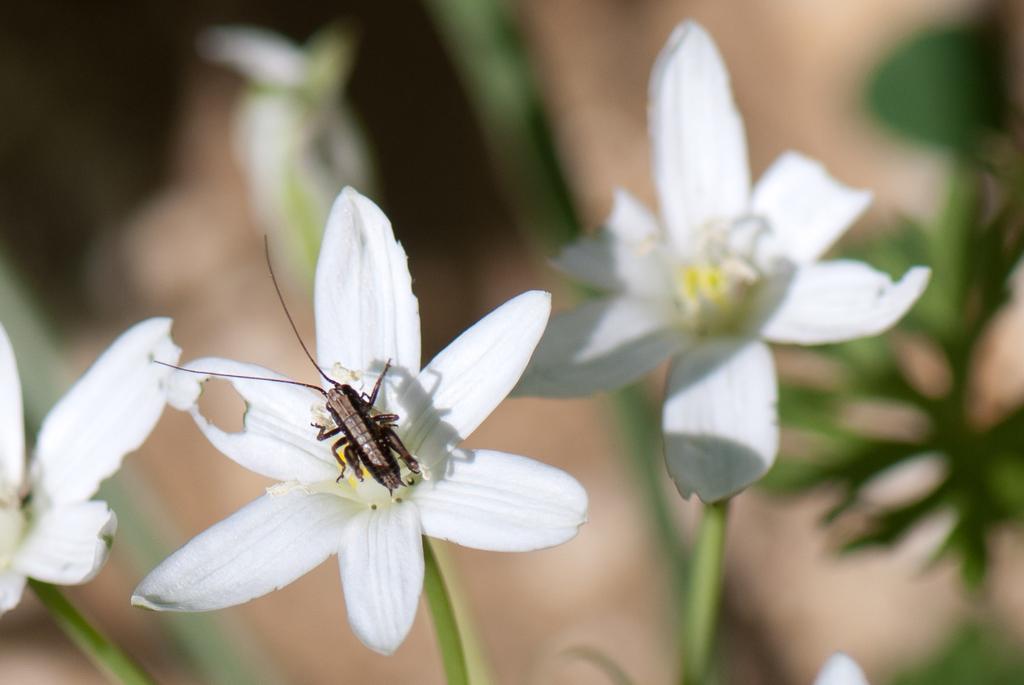Could you give a brief overview of what you see in this image? In this picture we can see an insect in the middle of the image on the flower, and we can find few plants. 